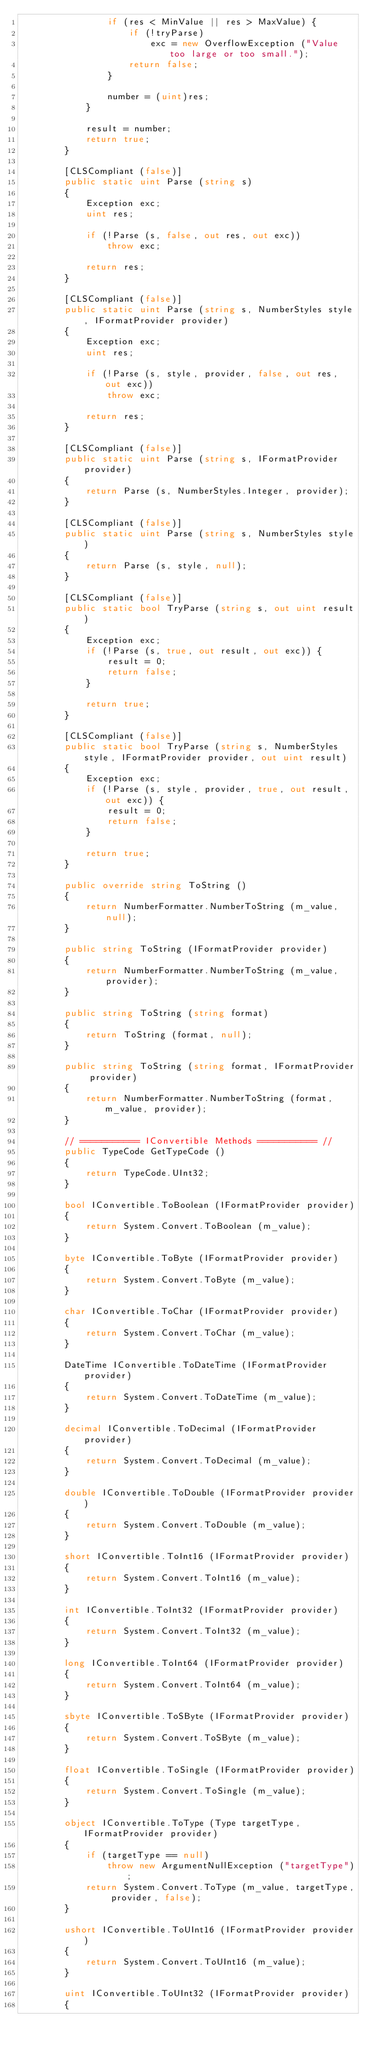<code> <loc_0><loc_0><loc_500><loc_500><_C#_>				if (res < MinValue || res > MaxValue) {
					if (!tryParse)
						exc = new OverflowException ("Value too large or too small.");
					return false;
				}

				number = (uint)res;
			}

			result = number;
			return true;
		}

		[CLSCompliant (false)]
		public static uint Parse (string s) 
		{
			Exception exc;
			uint res;

			if (!Parse (s, false, out res, out exc))
				throw exc;

			return res;
		}

		[CLSCompliant (false)]
		public static uint Parse (string s, NumberStyles style, IFormatProvider provider) 
		{
			Exception exc;
			uint res;

			if (!Parse (s, style, provider, false, out res, out exc))
				throw exc;

			return res;
		}

		[CLSCompliant (false)]
		public static uint Parse (string s, IFormatProvider provider)
		{
			return Parse (s, NumberStyles.Integer, provider);
		}

		[CLSCompliant (false)]
		public static uint Parse (string s, NumberStyles style)
		{
			return Parse (s, style, null);
		}

		[CLSCompliant (false)]
		public static bool TryParse (string s, out uint result) 
		{
			Exception exc;
			if (!Parse (s, true, out result, out exc)) {
				result = 0;
				return false;
			}

			return true;
		}

		[CLSCompliant (false)]
		public static bool TryParse (string s, NumberStyles style, IFormatProvider provider, out uint result) 
		{
			Exception exc;
			if (!Parse (s, style, provider, true, out result, out exc)) {
				result = 0;
				return false;
			}

			return true;
		}

		public override string ToString ()
		{
			return NumberFormatter.NumberToString (m_value, null);
		}

		public string ToString (IFormatProvider provider)
		{
			return NumberFormatter.NumberToString (m_value, provider);
		}

		public string ToString (string format)
		{
			return ToString (format, null);
		}

		public string ToString (string format, IFormatProvider provider)
		{
			return NumberFormatter.NumberToString (format, m_value, provider);
		}

		// =========== IConvertible Methods =========== //
		public TypeCode GetTypeCode ()
		{
			return TypeCode.UInt32;
		}

		bool IConvertible.ToBoolean (IFormatProvider provider)
		{
			return System.Convert.ToBoolean (m_value);
		}

		byte IConvertible.ToByte (IFormatProvider provider)
		{
			return System.Convert.ToByte (m_value);
		}

		char IConvertible.ToChar (IFormatProvider provider)
		{
			return System.Convert.ToChar (m_value);
		}

		DateTime IConvertible.ToDateTime (IFormatProvider provider)
		{
			return System.Convert.ToDateTime (m_value);
		}

		decimal IConvertible.ToDecimal (IFormatProvider provider)
		{
			return System.Convert.ToDecimal (m_value);
		}

		double IConvertible.ToDouble (IFormatProvider provider)
		{
			return System.Convert.ToDouble (m_value);
		}

		short IConvertible.ToInt16 (IFormatProvider provider)
		{
			return System.Convert.ToInt16 (m_value);
		}

		int IConvertible.ToInt32 (IFormatProvider provider)
		{
			return System.Convert.ToInt32 (m_value);
		}

		long IConvertible.ToInt64 (IFormatProvider provider)
		{
			return System.Convert.ToInt64 (m_value);
		}

		sbyte IConvertible.ToSByte (IFormatProvider provider)
		{
			return System.Convert.ToSByte (m_value);
		}
		
		float IConvertible.ToSingle (IFormatProvider provider)
		{
			return System.Convert.ToSingle (m_value);
		}

		object IConvertible.ToType (Type targetType, IFormatProvider provider)
		{
			if (targetType == null)
				throw new ArgumentNullException ("targetType");
			return System.Convert.ToType (m_value, targetType, provider, false);
		}

		ushort IConvertible.ToUInt16 (IFormatProvider provider)
		{
			return System.Convert.ToUInt16 (m_value);
		}

		uint IConvertible.ToUInt32 (IFormatProvider provider)
		{</code> 